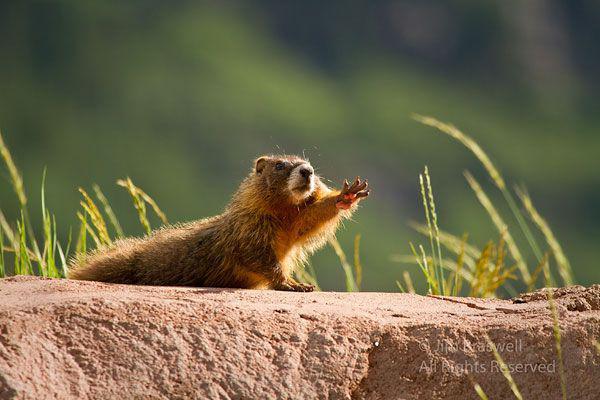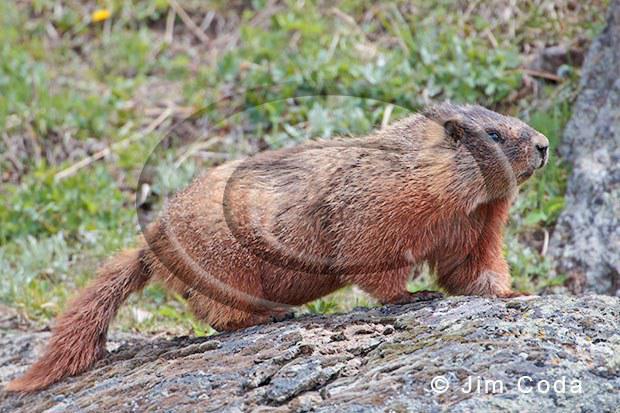The first image is the image on the left, the second image is the image on the right. Evaluate the accuracy of this statement regarding the images: "There are two marmots standing up on their hind legs". Is it true? Answer yes or no. No. 